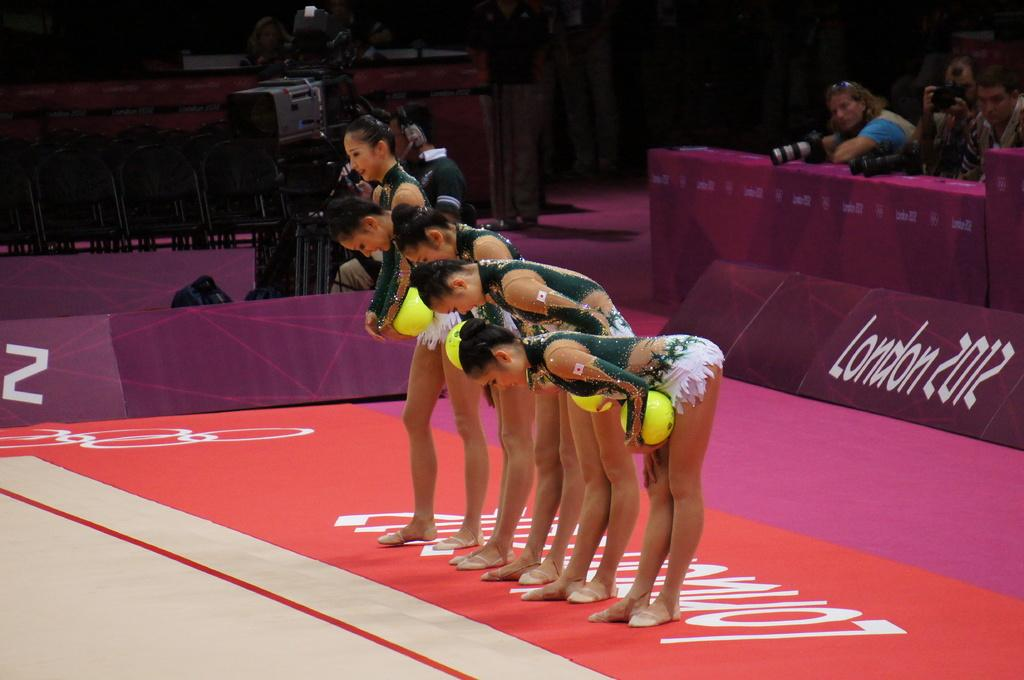<image>
Create a compact narrative representing the image presented. gymnists that are bowing in front of people in london 2012 